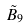Convert formula to latex. <formula><loc_0><loc_0><loc_500><loc_500>\tilde { B } _ { 9 }</formula> 